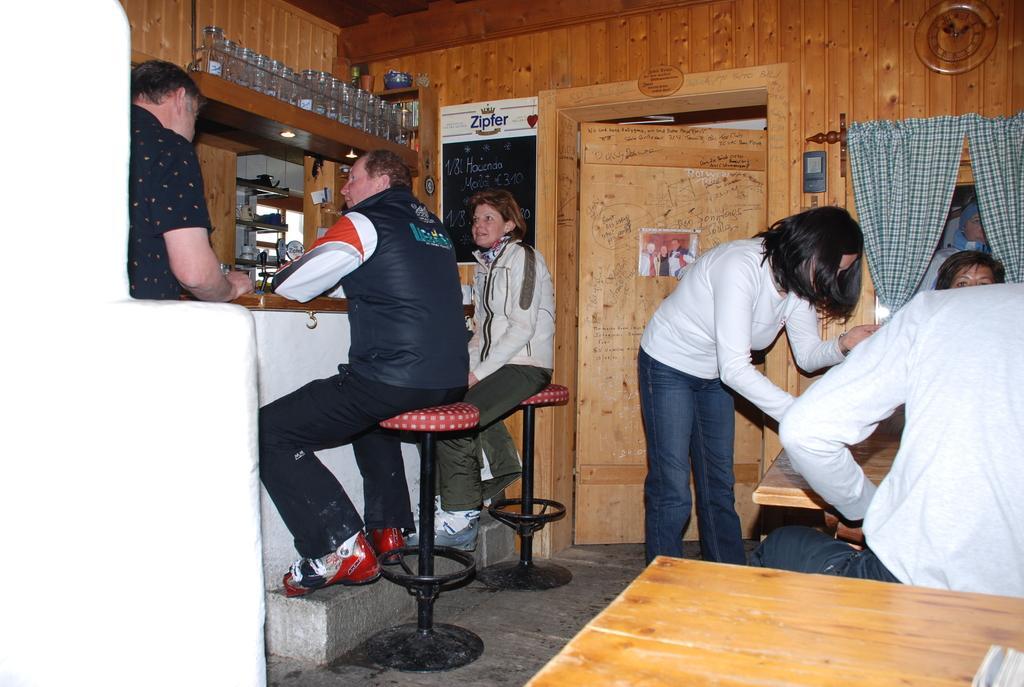Could you give a brief overview of what you see in this image? Two persons are sitting on the stools at here in the middle there is a door. And a woman is standing at right 